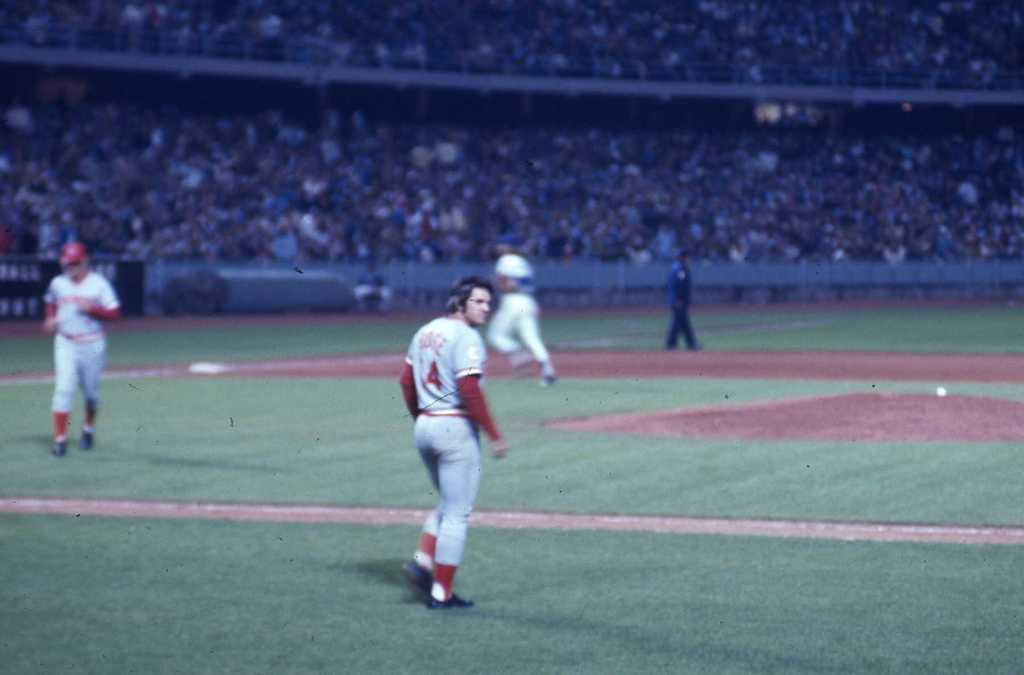<image>
Relay a brief, clear account of the picture shown. A baseball player wearing a number 4 uniform turns to look over his shoulder as he heads onto the field. 